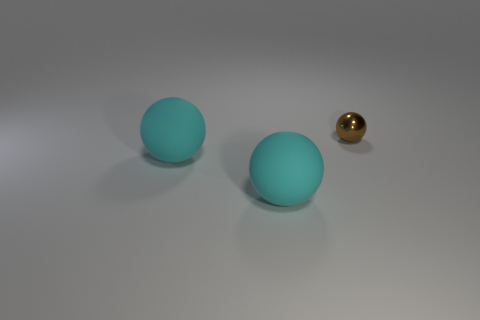Subtract all rubber spheres. How many spheres are left? 1 Subtract all brown balls. How many balls are left? 2 Subtract 1 spheres. How many spheres are left? 2 Add 2 big purple matte cylinders. How many big purple matte cylinders exist? 2 Add 3 big blue cubes. How many objects exist? 6 Subtract 1 brown spheres. How many objects are left? 2 Subtract all blue balls. Subtract all green cubes. How many balls are left? 3 Subtract all yellow cubes. How many yellow spheres are left? 0 Subtract all large cyan balls. Subtract all small objects. How many objects are left? 0 Add 3 large cyan matte objects. How many large cyan matte objects are left? 5 